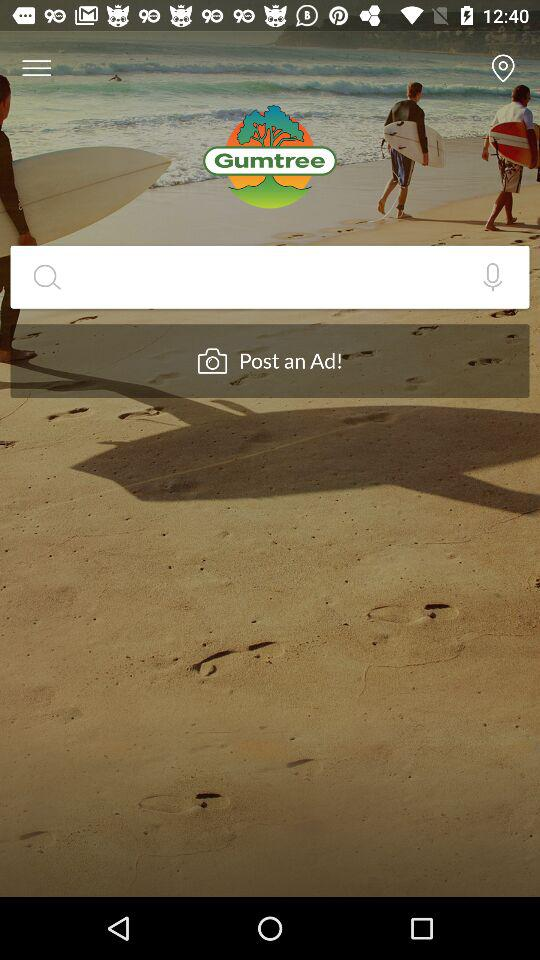What is the name of the application? The name of the application is "Gumtree". 